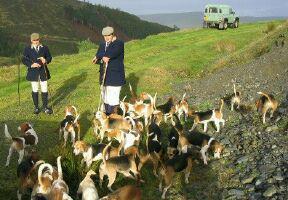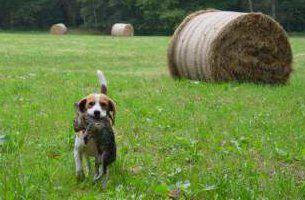The first image is the image on the left, the second image is the image on the right. Assess this claim about the two images: "One image has no more than one dog.". Correct or not? Answer yes or no. Yes. The first image is the image on the left, the second image is the image on the right. Considering the images on both sides, is "in at least one photo a man is using a walking stick on the grass" valid? Answer yes or no. Yes. 